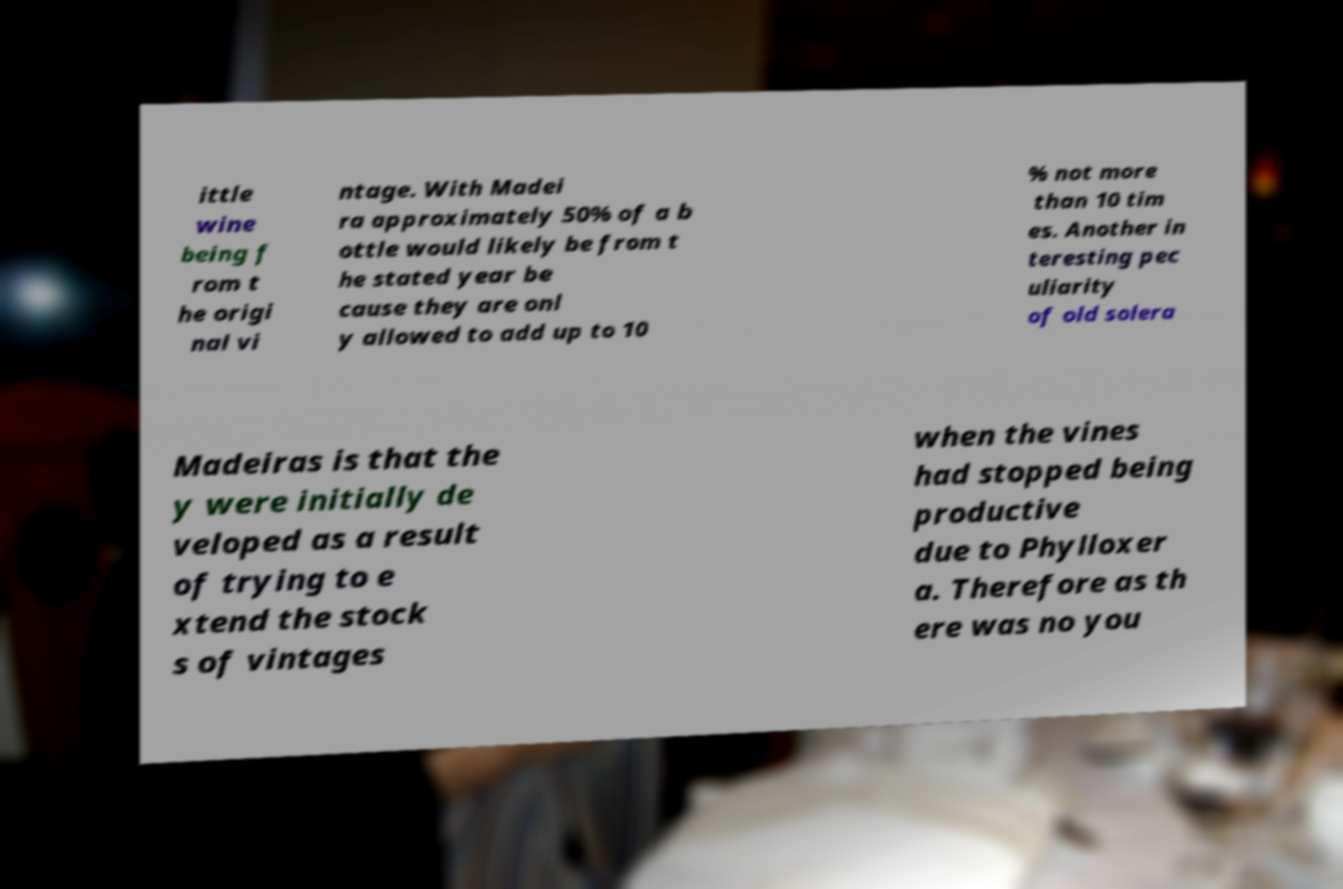Can you accurately transcribe the text from the provided image for me? ittle wine being f rom t he origi nal vi ntage. With Madei ra approximately 50% of a b ottle would likely be from t he stated year be cause they are onl y allowed to add up to 10 % not more than 10 tim es. Another in teresting pec uliarity of old solera Madeiras is that the y were initially de veloped as a result of trying to e xtend the stock s of vintages when the vines had stopped being productive due to Phylloxer a. Therefore as th ere was no you 